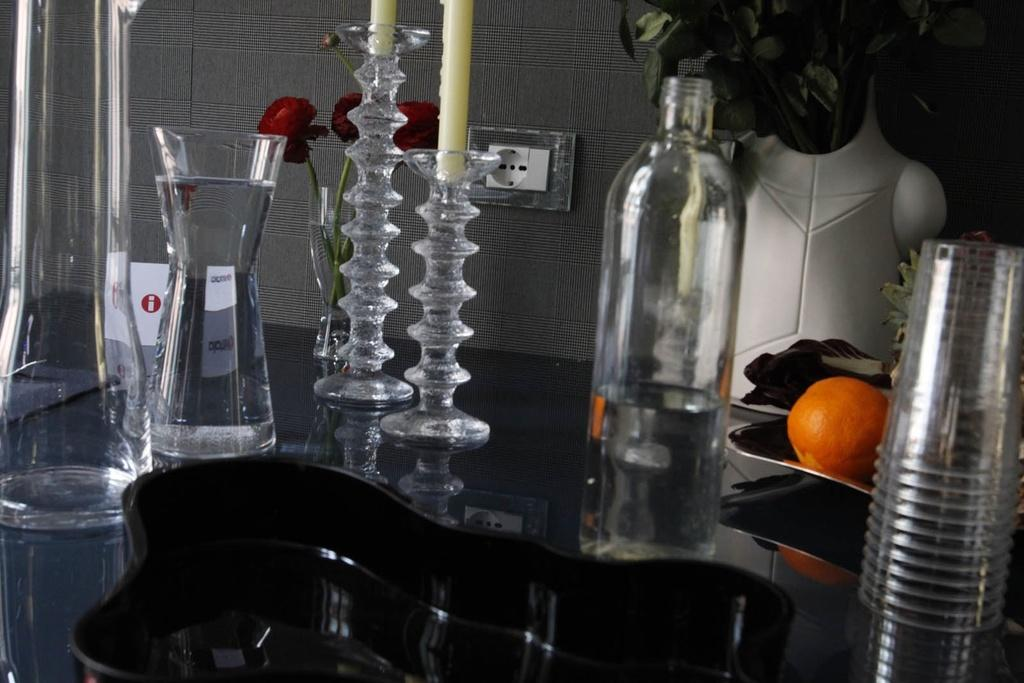What type of food item is on the table in the image? There is a fruit on the table. What type of container is on the table? There is a bottle on the table. What type of lighting source is on the table? There are candles on the table. What type of decorative item is on the table? There are flowers on the table. What type of drinking vessel is on the table? There is a glass on the table. What type of surface is on the table? There is a tray on the table. What type of living organism is on the table? There is a plant on the table. What type of drinking vessels are on the table? There are cups on the table. How many balls are on the table in the image? There are no balls present on the table in the image. What type of utensil is used for eating in the image? There is no fork present in the image, and the type of utensil used for eating cannot be determined from the image. 